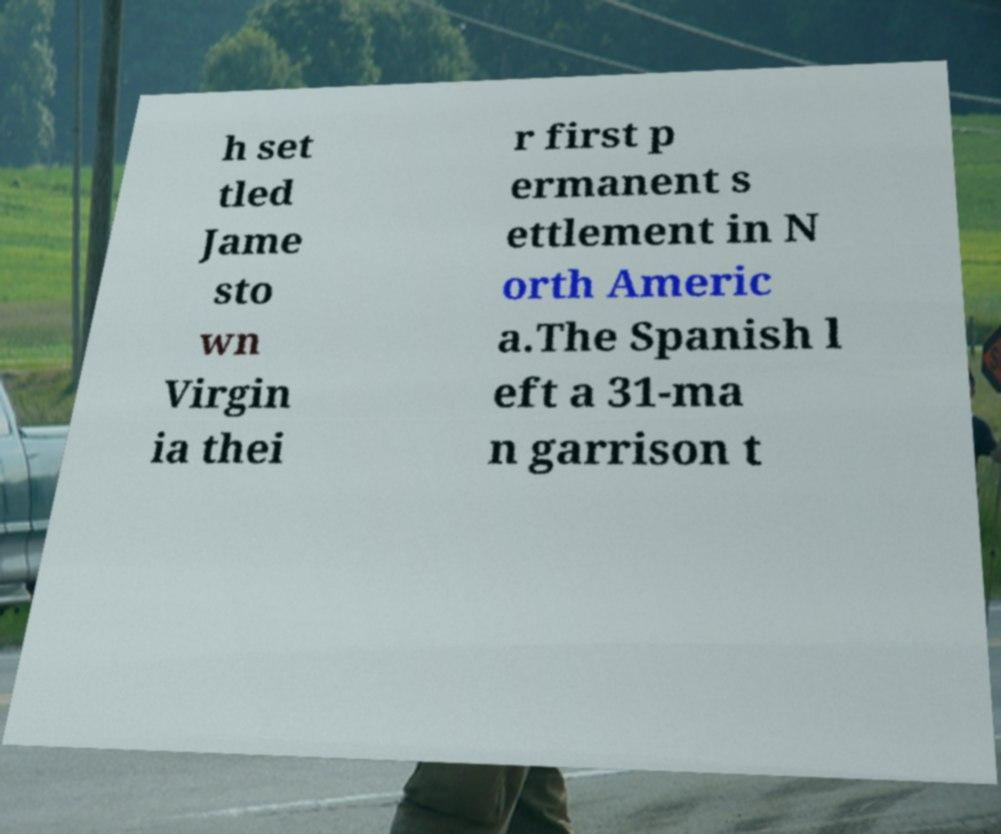Could you extract and type out the text from this image? h set tled Jame sto wn Virgin ia thei r first p ermanent s ettlement in N orth Americ a.The Spanish l eft a 31-ma n garrison t 